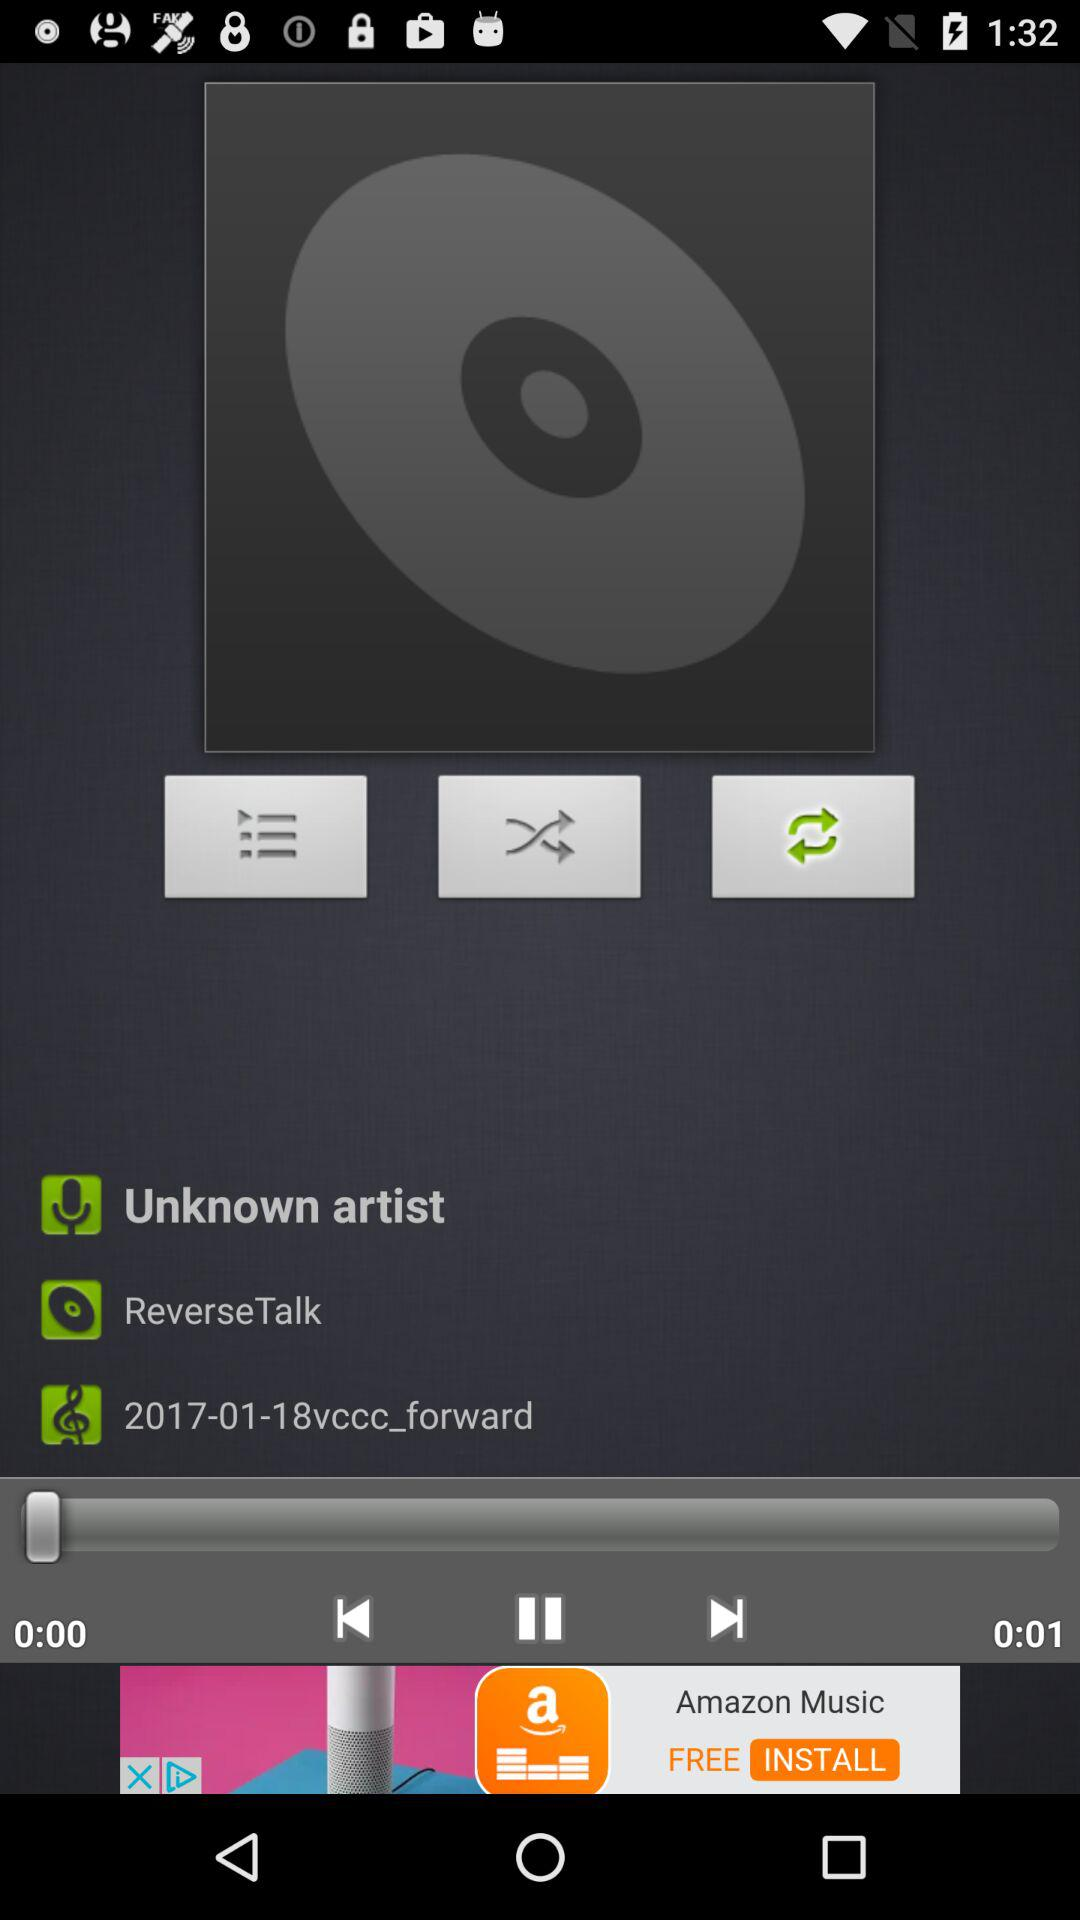What is the artist's name? The artist's name is unknown. 